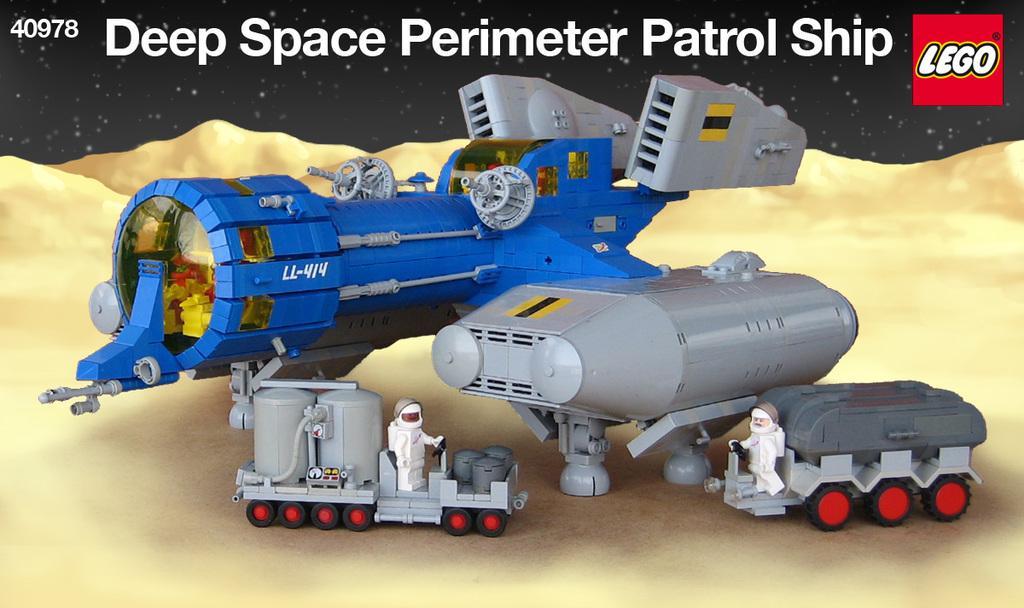Could you give a brief overview of what you see in this image? In this image I can see toy vehicle, the vehicle is in blue and gray color. In front I can see two toys which are in white color and I can see black color background. 